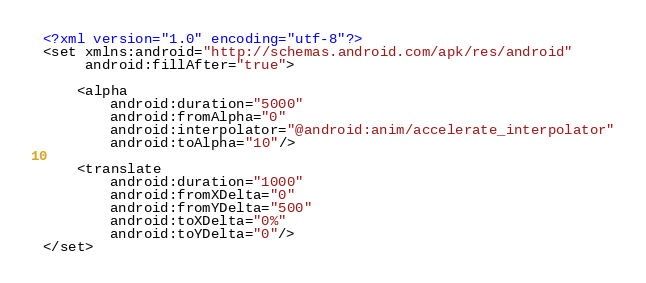<code> <loc_0><loc_0><loc_500><loc_500><_XML_><?xml version="1.0" encoding="utf-8"?>
<set xmlns:android="http://schemas.android.com/apk/res/android"
     android:fillAfter="true">

    <alpha
        android:duration="5000"
        android:fromAlpha="0"
        android:interpolator="@android:anim/accelerate_interpolator"
        android:toAlpha="10"/>

    <translate
        android:duration="1000"
        android:fromXDelta="0"
        android:fromYDelta="500"
        android:toXDelta="0%"
        android:toYDelta="0"/>
</set></code> 